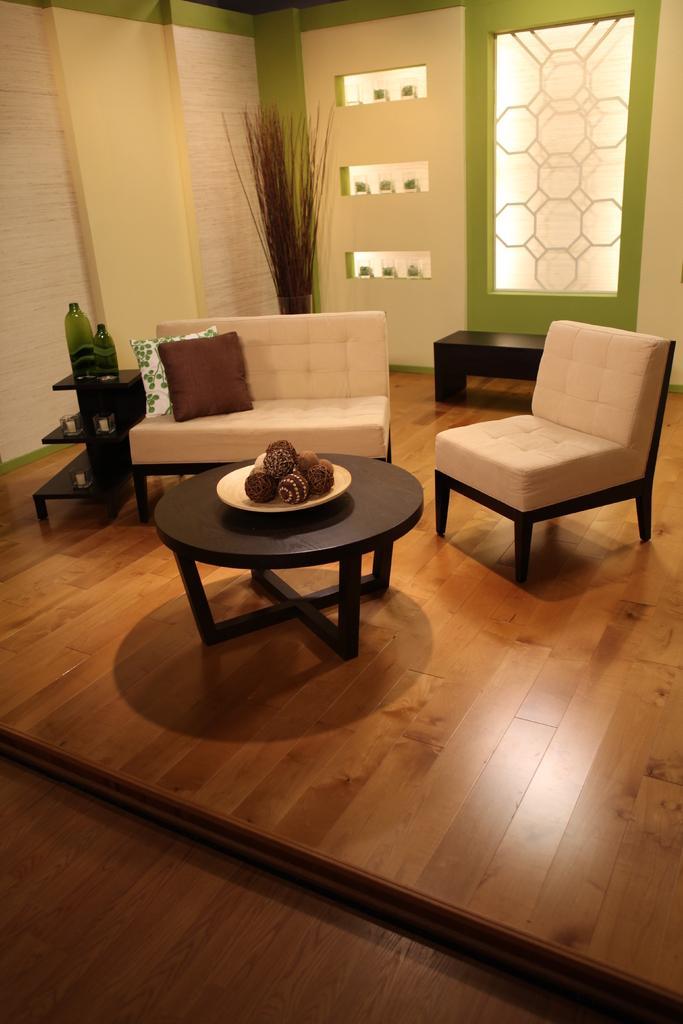How would you summarize this image in a sentence or two? In this image I can see the brown colored floor, a black colored table with a plate on it and on the plate I can see few objects. I can see few couches which are cream in color and few cushions on the couch. I can see two bottles, the cream and green colored walls, few glass surfaces and few other objects. 